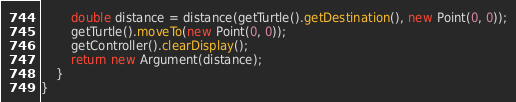Convert code to text. <code><loc_0><loc_0><loc_500><loc_500><_Java_>		double distance = distance(getTurtle().getDestination(), new Point(0, 0));
		getTurtle().moveTo(new Point(0, 0));
		getController().clearDisplay();
		return new Argument(distance);
	}
}</code> 